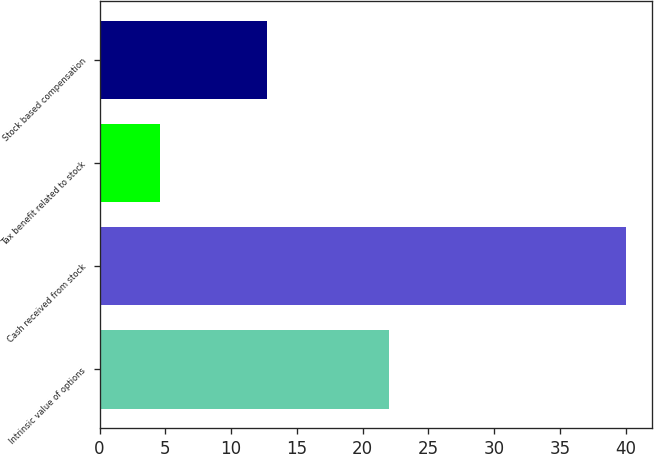Convert chart. <chart><loc_0><loc_0><loc_500><loc_500><bar_chart><fcel>Intrinsic value of options<fcel>Cash received from stock<fcel>Tax benefit related to stock<fcel>Stock based compensation<nl><fcel>22<fcel>40<fcel>4.6<fcel>12.7<nl></chart> 